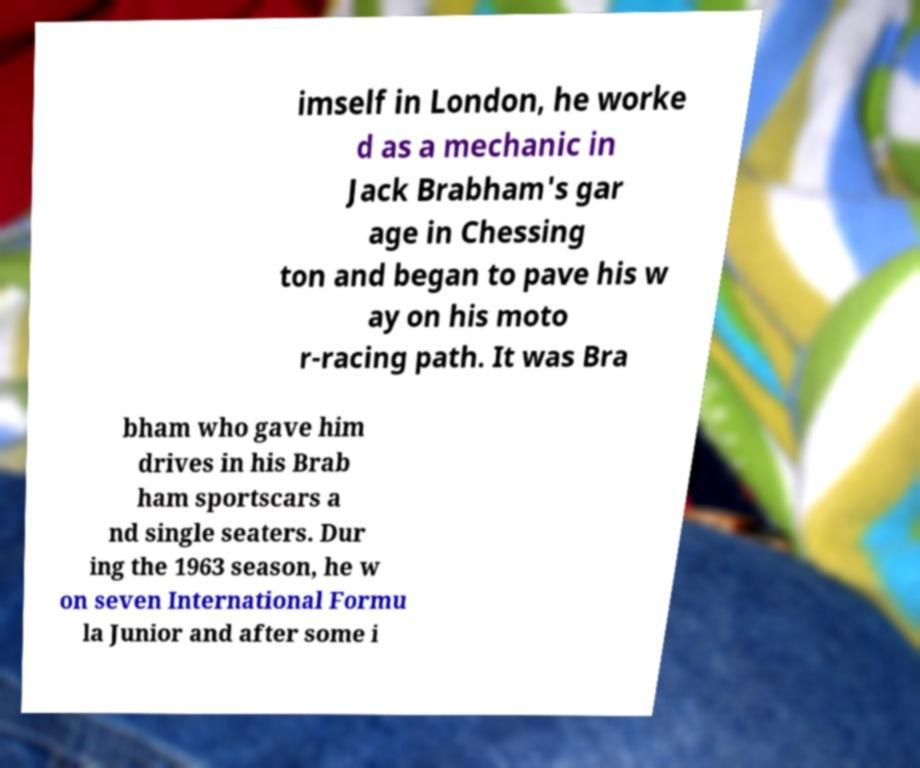Please read and relay the text visible in this image. What does it say? imself in London, he worke d as a mechanic in Jack Brabham's gar age in Chessing ton and began to pave his w ay on his moto r-racing path. It was Bra bham who gave him drives in his Brab ham sportscars a nd single seaters. Dur ing the 1963 season, he w on seven International Formu la Junior and after some i 